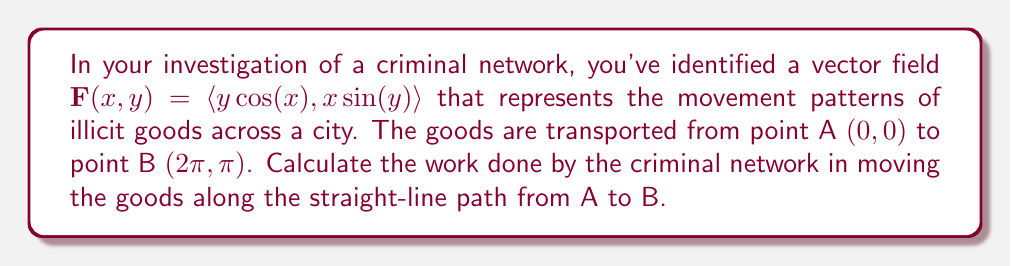Help me with this question. To solve this problem, we need to calculate the line integral of the vector field along the straight-line path from A to B. Here's how we can approach this:

1) First, we need to parameterize the straight line from A $(0,0)$ to B $(2\pi,\pi)$. We can do this using:

   $x(t) = 2\pi t$
   $y(t) = \pi t$
   where $0 \leq t \leq 1$

2) The derivative of this path with respect to t is:
   $\frac{d\mathbf{r}}{dt} = \langle 2\pi, \pi \rangle$

3) Now, we need to evaluate $\mathbf{F}$ along this path:
   $\mathbf{F}(x(t),y(t)) = \langle \pi t \cos(2\pi t), 2\pi t \sin(\pi t) \rangle$

4) The work done is given by the line integral:

   $W = \int_C \mathbf{F} \cdot d\mathbf{r} = \int_0^1 \mathbf{F}(x(t),y(t)) \cdot \frac{d\mathbf{r}}{dt} dt$

5) Substituting our expressions:

   $W = \int_0^1 [\pi t \cos(2\pi t) \cdot 2\pi + 2\pi t \sin(\pi t) \cdot \pi] dt$

6) Simplifying:

   $W = \int_0^1 [2\pi^2 t \cos(2\pi t) + 2\pi^2 t \sin(\pi t)] dt$

7) This integral doesn't have an elementary antiderivative, so we need to use numerical integration. Using a computer algebra system or numerical integration technique, we find:

   $W \approx 9.8696$

Thus, the work done by the criminal network in moving the goods along this path is approximately 9.8696 units.
Answer: The work done by the criminal network is approximately 9.8696 units. 